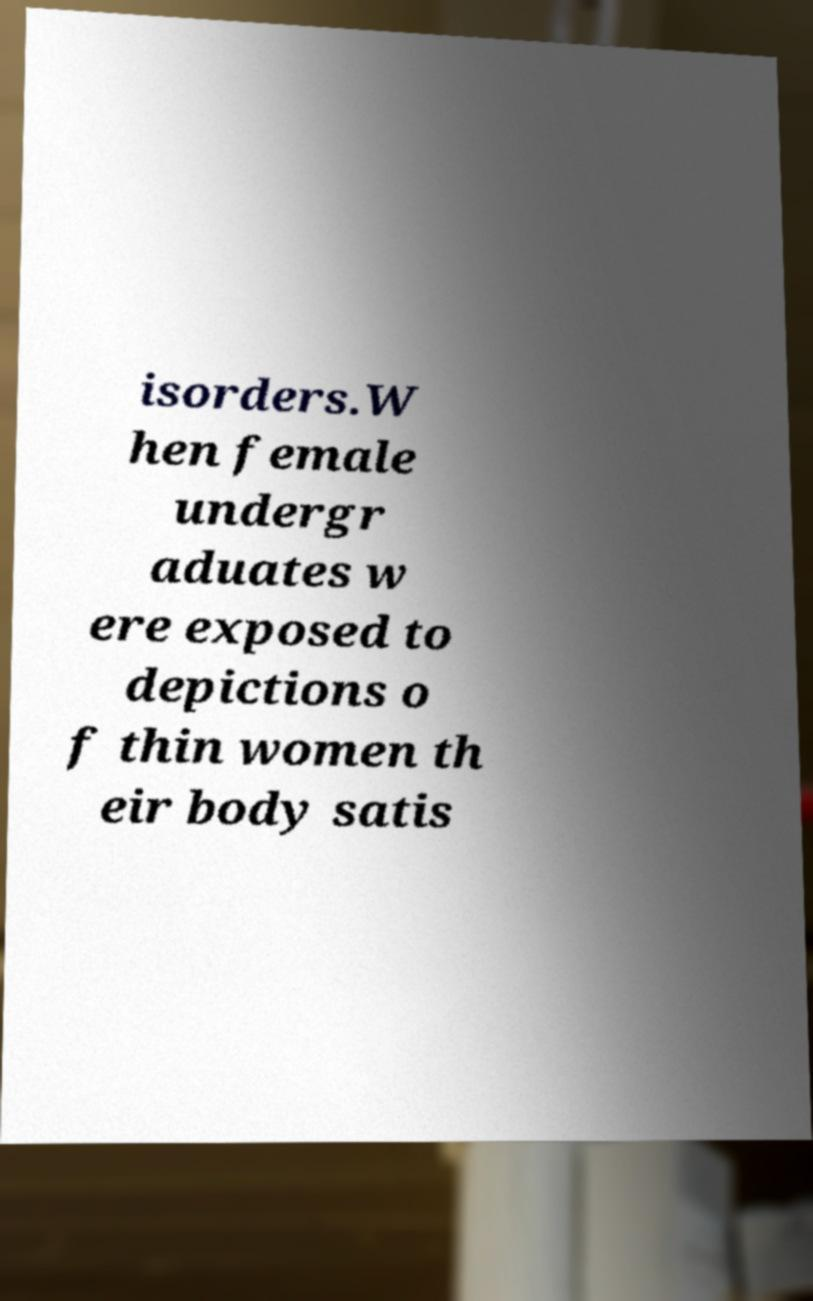Can you accurately transcribe the text from the provided image for me? isorders.W hen female undergr aduates w ere exposed to depictions o f thin women th eir body satis 